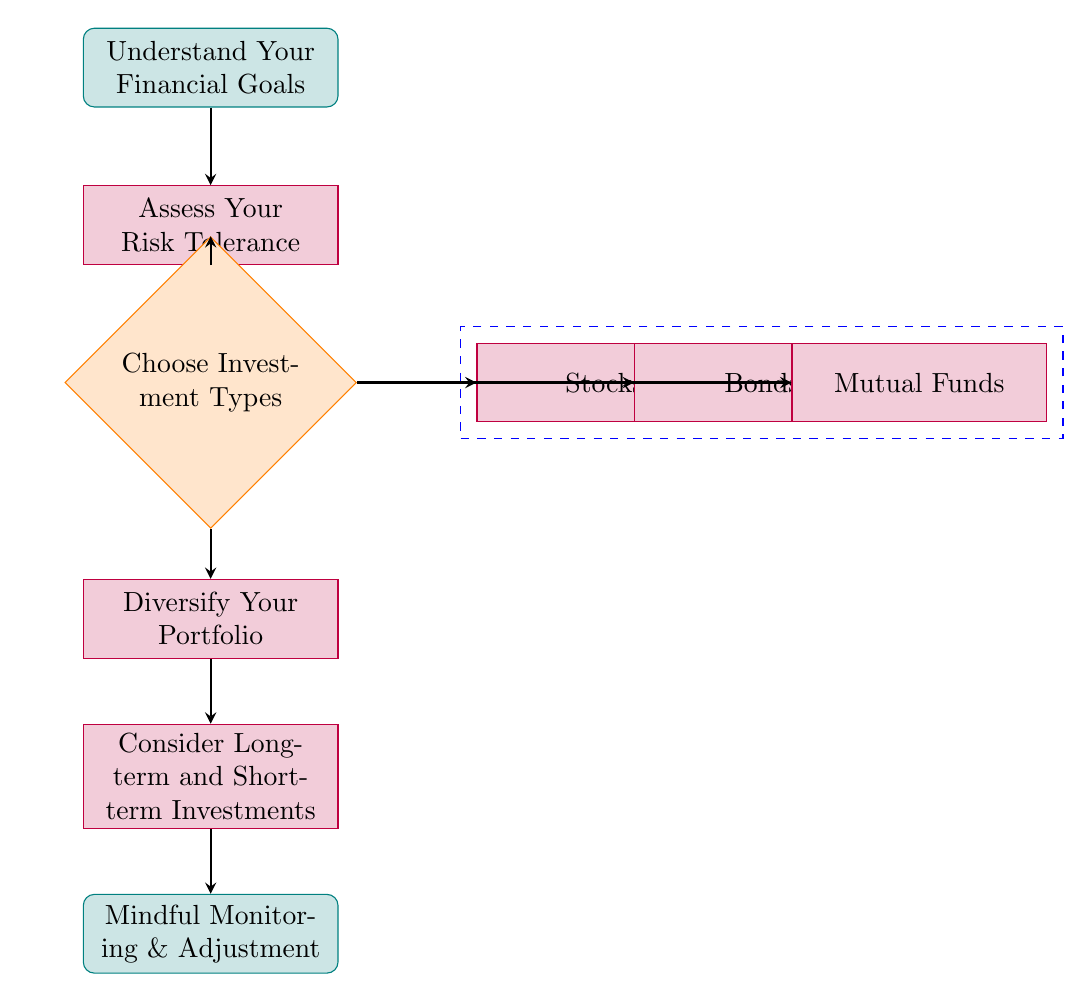What is the first step in starting an investment portfolio? The first node in the flow chart indicates that the initial step is to "Understand Your Financial Goals". This is the first action you need to take before proceeding to any other steps in the process.
Answer: Understand Your Financial Goals How many types of investments are mentioned? The diagram shows three investment types as sub-nodes from the "Choose Investment Types" node: Stocks, Bonds, and Mutual Funds, which totals to three distinct types of investments.
Answer: 3 What is the final step in the investment process according to the flow chart? The last node in the flow chart shows "Mindful Monitoring & Adjustment" as the final step, indicating that regular check-ins are necessary.
Answer: Mindful Monitoring & Adjustment Which node comes after assessing risk tolerance? Based on the connections in the diagram, "Choose Investment Types" is the node that follows "Assess Your Risk Tolerance", as indicated by the arrow showing the flow from one to the other.
Answer: Choose Investment Types What types of investments are included in the diagram? The diagram details three specific types of investments: Stocks, Bonds, and Mutual Funds. Each is a sub-node connected to the "Choose Investment Types" node.
Answer: Stocks, Bonds, Mutual Funds Why is diversification important in an investment portfolio? While the diagram doesn't explicitly state the reasons, diversification is implied as an important step to manage risk and ensure a balanced portfolio, as it comes directly after choosing investment types.
Answer: To manage risk What pathway is formed when choosing investment types? The pathway forms from "Choose Investment Types" to three branches: Stocks, Bonds, and Mutual Funds. This indicates that from the decision node, you can explore three different types of investments.
Answer: Stocks, Bonds, Mutual Funds What should be monitored and adjusted mindfully? The last node specifies "Mindful Monitoring & Adjustment," indicating that one should regularly check their investments and make any necessary changes without becoming stressed.
Answer: Investments 